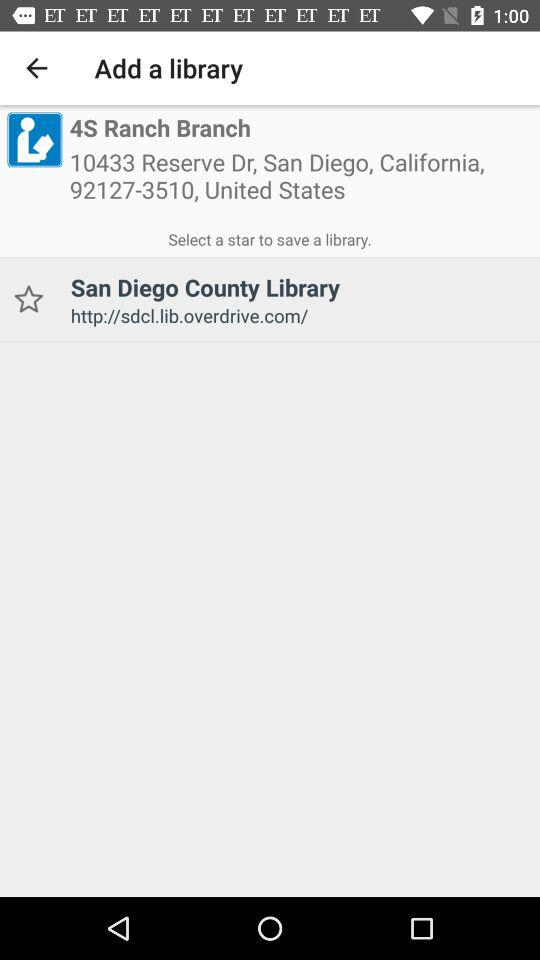What is the address of "4S Ranch Branch"? The address of "4S Ranch Branch" is 10433 Reserve Dr, San Diego, California, 92127-3510, United States. 